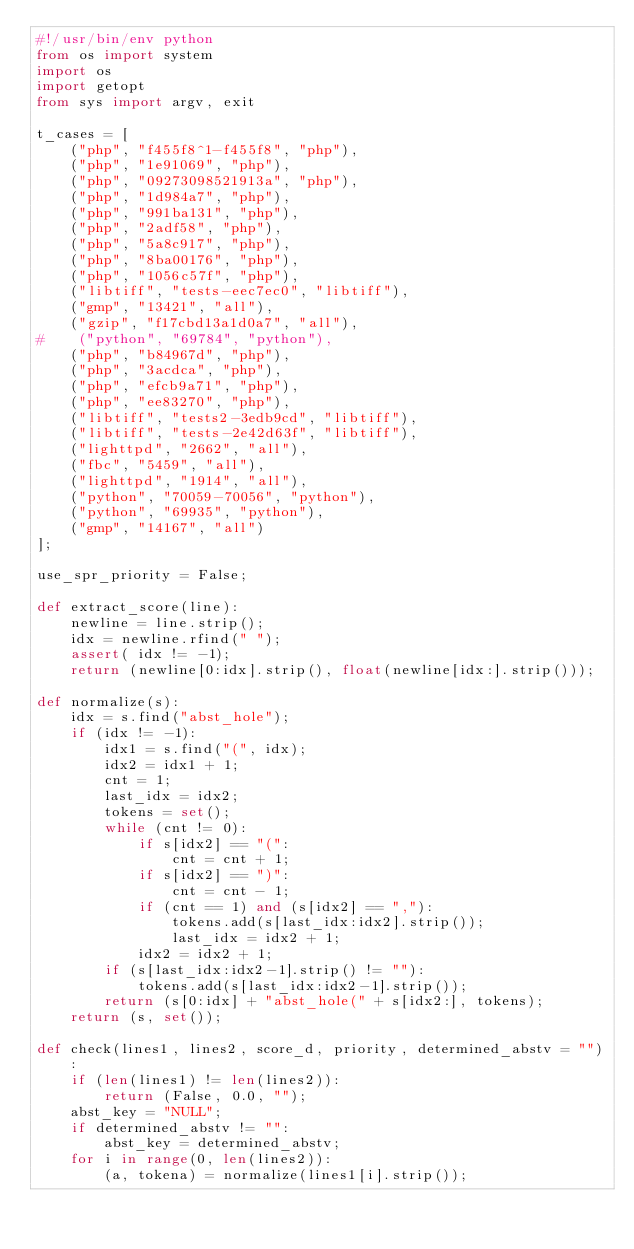<code> <loc_0><loc_0><loc_500><loc_500><_Python_>#!/usr/bin/env python
from os import system
import os
import getopt
from sys import argv, exit

t_cases = [
    ("php", "f455f8^1-f455f8", "php"),
    ("php", "1e91069", "php"),
    ("php", "09273098521913a", "php"),
    ("php", "1d984a7", "php"),
    ("php", "991ba131", "php"),
    ("php", "2adf58", "php"),
    ("php", "5a8c917", "php"),
    ("php", "8ba00176", "php"),
    ("php", "1056c57f", "php"),
    ("libtiff", "tests-eec7ec0", "libtiff"),
    ("gmp", "13421", "all"),
    ("gzip", "f17cbd13a1d0a7", "all"),
#    ("python", "69784", "python"),
    ("php", "b84967d", "php"),
    ("php", "3acdca", "php"),
    ("php", "efcb9a71", "php"),
    ("php", "ee83270", "php"),
    ("libtiff", "tests2-3edb9cd", "libtiff"),
    ("libtiff", "tests-2e42d63f", "libtiff"),
    ("lighttpd", "2662", "all"),
    ("fbc", "5459", "all"),
    ("lighttpd", "1914", "all"),
    ("python", "70059-70056", "python"),
    ("python", "69935", "python"),
    ("gmp", "14167", "all")
];

use_spr_priority = False;

def extract_score(line):
    newline = line.strip();
    idx = newline.rfind(" ");
    assert( idx != -1);
    return (newline[0:idx].strip(), float(newline[idx:].strip()));

def normalize(s):
    idx = s.find("abst_hole");
    if (idx != -1):
        idx1 = s.find("(", idx);
        idx2 = idx1 + 1;
        cnt = 1;
        last_idx = idx2;
        tokens = set();
        while (cnt != 0):
            if s[idx2] == "(":
                cnt = cnt + 1;
            if s[idx2] == ")":
                cnt = cnt - 1;
            if (cnt == 1) and (s[idx2] == ","):
                tokens.add(s[last_idx:idx2].strip());
                last_idx = idx2 + 1;
            idx2 = idx2 + 1;
        if (s[last_idx:idx2-1].strip() != ""):
            tokens.add(s[last_idx:idx2-1].strip());
        return (s[0:idx] + "abst_hole(" + s[idx2:], tokens);
    return (s, set());

def check(lines1, lines2, score_d, priority, determined_abstv = ""):
    if (len(lines1) != len(lines2)):
        return (False, 0.0, "");
    abst_key = "NULL";
    if determined_abstv != "":
        abst_key = determined_abstv;
    for i in range(0, len(lines2)):
        (a, tokena) = normalize(lines1[i].strip());</code> 